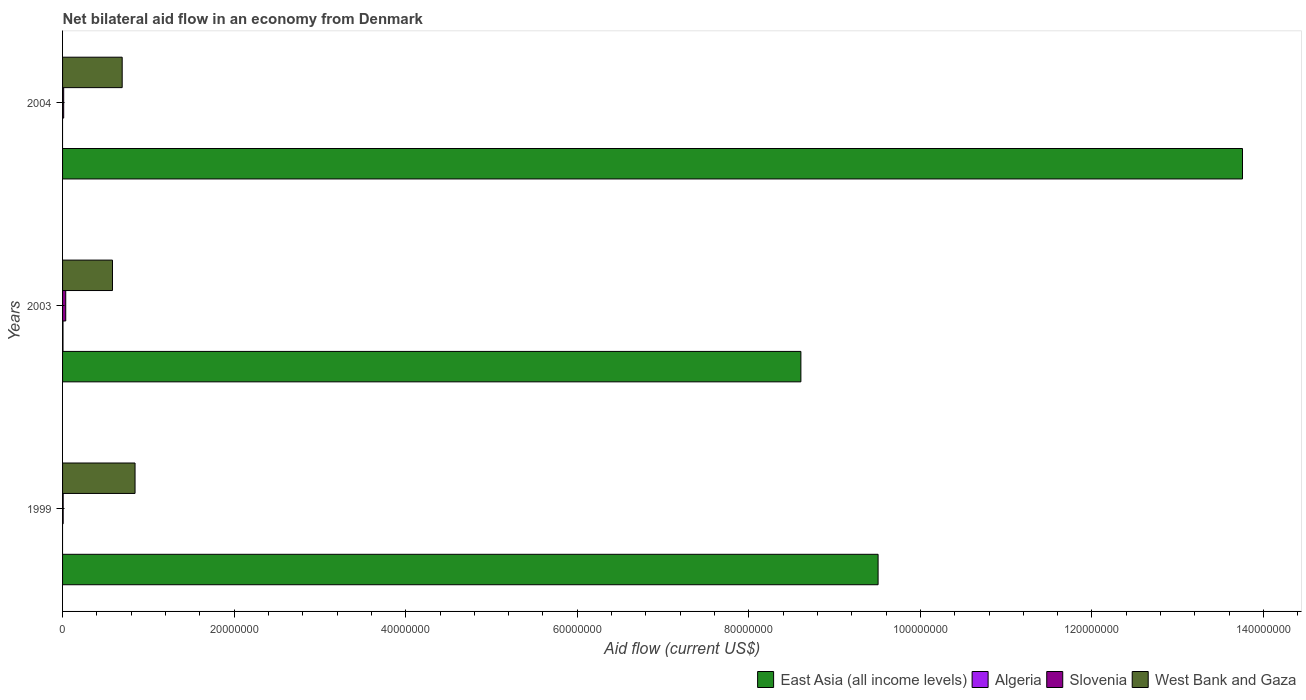Are the number of bars per tick equal to the number of legend labels?
Your response must be concise. No. Are the number of bars on each tick of the Y-axis equal?
Your answer should be compact. No. Across all years, what is the minimum net bilateral aid flow in East Asia (all income levels)?
Provide a short and direct response. 8.61e+07. In which year was the net bilateral aid flow in Algeria maximum?
Provide a short and direct response. 2003. What is the total net bilateral aid flow in West Bank and Gaza in the graph?
Keep it short and to the point. 2.12e+07. What is the difference between the net bilateral aid flow in West Bank and Gaza in 1999 and that in 2004?
Offer a terse response. 1.50e+06. What is the difference between the net bilateral aid flow in East Asia (all income levels) in 2004 and the net bilateral aid flow in Slovenia in 2003?
Provide a short and direct response. 1.37e+08. What is the average net bilateral aid flow in Algeria per year?
Provide a short and direct response. 1.67e+04. In the year 2004, what is the difference between the net bilateral aid flow in East Asia (all income levels) and net bilateral aid flow in West Bank and Gaza?
Offer a very short reply. 1.31e+08. What is the ratio of the net bilateral aid flow in East Asia (all income levels) in 1999 to that in 2003?
Your answer should be very brief. 1.1. Is the net bilateral aid flow in West Bank and Gaza in 1999 less than that in 2004?
Offer a terse response. No. What is the difference between the highest and the second highest net bilateral aid flow in Slovenia?
Your answer should be compact. 2.40e+05. What is the difference between the highest and the lowest net bilateral aid flow in East Asia (all income levels)?
Offer a very short reply. 5.15e+07. In how many years, is the net bilateral aid flow in Slovenia greater than the average net bilateral aid flow in Slovenia taken over all years?
Your answer should be very brief. 1. Is the sum of the net bilateral aid flow in East Asia (all income levels) in 2003 and 2004 greater than the maximum net bilateral aid flow in Slovenia across all years?
Provide a short and direct response. Yes. Is it the case that in every year, the sum of the net bilateral aid flow in West Bank and Gaza and net bilateral aid flow in Algeria is greater than the net bilateral aid flow in East Asia (all income levels)?
Your answer should be very brief. No. How many years are there in the graph?
Provide a short and direct response. 3. Are the values on the major ticks of X-axis written in scientific E-notation?
Ensure brevity in your answer.  No. Where does the legend appear in the graph?
Keep it short and to the point. Bottom right. How are the legend labels stacked?
Provide a short and direct response. Horizontal. What is the title of the graph?
Ensure brevity in your answer.  Net bilateral aid flow in an economy from Denmark. Does "Honduras" appear as one of the legend labels in the graph?
Make the answer very short. No. What is the label or title of the X-axis?
Ensure brevity in your answer.  Aid flow (current US$). What is the label or title of the Y-axis?
Make the answer very short. Years. What is the Aid flow (current US$) in East Asia (all income levels) in 1999?
Offer a terse response. 9.51e+07. What is the Aid flow (current US$) in Algeria in 1999?
Give a very brief answer. 0. What is the Aid flow (current US$) of Slovenia in 1999?
Your answer should be compact. 7.00e+04. What is the Aid flow (current US$) in West Bank and Gaza in 1999?
Make the answer very short. 8.45e+06. What is the Aid flow (current US$) in East Asia (all income levels) in 2003?
Your answer should be compact. 8.61e+07. What is the Aid flow (current US$) in Algeria in 2003?
Ensure brevity in your answer.  5.00e+04. What is the Aid flow (current US$) in Slovenia in 2003?
Offer a very short reply. 3.70e+05. What is the Aid flow (current US$) in West Bank and Gaza in 2003?
Offer a terse response. 5.82e+06. What is the Aid flow (current US$) of East Asia (all income levels) in 2004?
Your response must be concise. 1.38e+08. What is the Aid flow (current US$) in West Bank and Gaza in 2004?
Provide a succinct answer. 6.95e+06. Across all years, what is the maximum Aid flow (current US$) of East Asia (all income levels)?
Give a very brief answer. 1.38e+08. Across all years, what is the maximum Aid flow (current US$) in West Bank and Gaza?
Your answer should be compact. 8.45e+06. Across all years, what is the minimum Aid flow (current US$) in East Asia (all income levels)?
Give a very brief answer. 8.61e+07. Across all years, what is the minimum Aid flow (current US$) of West Bank and Gaza?
Ensure brevity in your answer.  5.82e+06. What is the total Aid flow (current US$) of East Asia (all income levels) in the graph?
Provide a succinct answer. 3.19e+08. What is the total Aid flow (current US$) of Slovenia in the graph?
Provide a succinct answer. 5.70e+05. What is the total Aid flow (current US$) of West Bank and Gaza in the graph?
Your response must be concise. 2.12e+07. What is the difference between the Aid flow (current US$) of East Asia (all income levels) in 1999 and that in 2003?
Make the answer very short. 9.00e+06. What is the difference between the Aid flow (current US$) of Slovenia in 1999 and that in 2003?
Keep it short and to the point. -3.00e+05. What is the difference between the Aid flow (current US$) in West Bank and Gaza in 1999 and that in 2003?
Ensure brevity in your answer.  2.63e+06. What is the difference between the Aid flow (current US$) in East Asia (all income levels) in 1999 and that in 2004?
Offer a very short reply. -4.25e+07. What is the difference between the Aid flow (current US$) in West Bank and Gaza in 1999 and that in 2004?
Your answer should be compact. 1.50e+06. What is the difference between the Aid flow (current US$) of East Asia (all income levels) in 2003 and that in 2004?
Offer a very short reply. -5.15e+07. What is the difference between the Aid flow (current US$) of West Bank and Gaza in 2003 and that in 2004?
Ensure brevity in your answer.  -1.13e+06. What is the difference between the Aid flow (current US$) in East Asia (all income levels) in 1999 and the Aid flow (current US$) in Algeria in 2003?
Make the answer very short. 9.50e+07. What is the difference between the Aid flow (current US$) of East Asia (all income levels) in 1999 and the Aid flow (current US$) of Slovenia in 2003?
Your response must be concise. 9.47e+07. What is the difference between the Aid flow (current US$) of East Asia (all income levels) in 1999 and the Aid flow (current US$) of West Bank and Gaza in 2003?
Your answer should be compact. 8.92e+07. What is the difference between the Aid flow (current US$) of Slovenia in 1999 and the Aid flow (current US$) of West Bank and Gaza in 2003?
Offer a terse response. -5.75e+06. What is the difference between the Aid flow (current US$) in East Asia (all income levels) in 1999 and the Aid flow (current US$) in Slovenia in 2004?
Keep it short and to the point. 9.49e+07. What is the difference between the Aid flow (current US$) of East Asia (all income levels) in 1999 and the Aid flow (current US$) of West Bank and Gaza in 2004?
Give a very brief answer. 8.81e+07. What is the difference between the Aid flow (current US$) in Slovenia in 1999 and the Aid flow (current US$) in West Bank and Gaza in 2004?
Keep it short and to the point. -6.88e+06. What is the difference between the Aid flow (current US$) of East Asia (all income levels) in 2003 and the Aid flow (current US$) of Slovenia in 2004?
Make the answer very short. 8.59e+07. What is the difference between the Aid flow (current US$) of East Asia (all income levels) in 2003 and the Aid flow (current US$) of West Bank and Gaza in 2004?
Make the answer very short. 7.91e+07. What is the difference between the Aid flow (current US$) in Algeria in 2003 and the Aid flow (current US$) in West Bank and Gaza in 2004?
Offer a terse response. -6.90e+06. What is the difference between the Aid flow (current US$) in Slovenia in 2003 and the Aid flow (current US$) in West Bank and Gaza in 2004?
Ensure brevity in your answer.  -6.58e+06. What is the average Aid flow (current US$) of East Asia (all income levels) per year?
Keep it short and to the point. 1.06e+08. What is the average Aid flow (current US$) in Algeria per year?
Provide a succinct answer. 1.67e+04. What is the average Aid flow (current US$) in West Bank and Gaza per year?
Offer a very short reply. 7.07e+06. In the year 1999, what is the difference between the Aid flow (current US$) of East Asia (all income levels) and Aid flow (current US$) of Slovenia?
Make the answer very short. 9.50e+07. In the year 1999, what is the difference between the Aid flow (current US$) of East Asia (all income levels) and Aid flow (current US$) of West Bank and Gaza?
Your response must be concise. 8.66e+07. In the year 1999, what is the difference between the Aid flow (current US$) in Slovenia and Aid flow (current US$) in West Bank and Gaza?
Make the answer very short. -8.38e+06. In the year 2003, what is the difference between the Aid flow (current US$) of East Asia (all income levels) and Aid flow (current US$) of Algeria?
Your answer should be very brief. 8.60e+07. In the year 2003, what is the difference between the Aid flow (current US$) in East Asia (all income levels) and Aid flow (current US$) in Slovenia?
Ensure brevity in your answer.  8.57e+07. In the year 2003, what is the difference between the Aid flow (current US$) in East Asia (all income levels) and Aid flow (current US$) in West Bank and Gaza?
Your response must be concise. 8.02e+07. In the year 2003, what is the difference between the Aid flow (current US$) in Algeria and Aid flow (current US$) in Slovenia?
Keep it short and to the point. -3.20e+05. In the year 2003, what is the difference between the Aid flow (current US$) of Algeria and Aid flow (current US$) of West Bank and Gaza?
Your answer should be very brief. -5.77e+06. In the year 2003, what is the difference between the Aid flow (current US$) in Slovenia and Aid flow (current US$) in West Bank and Gaza?
Offer a very short reply. -5.45e+06. In the year 2004, what is the difference between the Aid flow (current US$) of East Asia (all income levels) and Aid flow (current US$) of Slovenia?
Your response must be concise. 1.37e+08. In the year 2004, what is the difference between the Aid flow (current US$) of East Asia (all income levels) and Aid flow (current US$) of West Bank and Gaza?
Provide a short and direct response. 1.31e+08. In the year 2004, what is the difference between the Aid flow (current US$) in Slovenia and Aid flow (current US$) in West Bank and Gaza?
Keep it short and to the point. -6.82e+06. What is the ratio of the Aid flow (current US$) of East Asia (all income levels) in 1999 to that in 2003?
Your answer should be very brief. 1.1. What is the ratio of the Aid flow (current US$) of Slovenia in 1999 to that in 2003?
Ensure brevity in your answer.  0.19. What is the ratio of the Aid flow (current US$) of West Bank and Gaza in 1999 to that in 2003?
Give a very brief answer. 1.45. What is the ratio of the Aid flow (current US$) in East Asia (all income levels) in 1999 to that in 2004?
Provide a short and direct response. 0.69. What is the ratio of the Aid flow (current US$) in Slovenia in 1999 to that in 2004?
Keep it short and to the point. 0.54. What is the ratio of the Aid flow (current US$) in West Bank and Gaza in 1999 to that in 2004?
Make the answer very short. 1.22. What is the ratio of the Aid flow (current US$) in East Asia (all income levels) in 2003 to that in 2004?
Give a very brief answer. 0.63. What is the ratio of the Aid flow (current US$) in Slovenia in 2003 to that in 2004?
Provide a succinct answer. 2.85. What is the ratio of the Aid flow (current US$) in West Bank and Gaza in 2003 to that in 2004?
Give a very brief answer. 0.84. What is the difference between the highest and the second highest Aid flow (current US$) of East Asia (all income levels)?
Provide a succinct answer. 4.25e+07. What is the difference between the highest and the second highest Aid flow (current US$) of West Bank and Gaza?
Provide a short and direct response. 1.50e+06. What is the difference between the highest and the lowest Aid flow (current US$) of East Asia (all income levels)?
Your answer should be compact. 5.15e+07. What is the difference between the highest and the lowest Aid flow (current US$) in West Bank and Gaza?
Your response must be concise. 2.63e+06. 